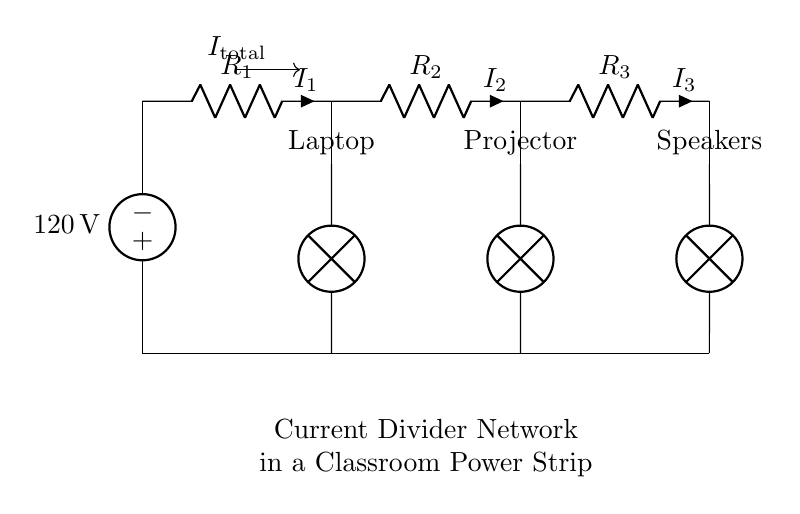What is the supply voltage in this circuit? The supply voltage is indicated in the circuit diagram as the voltage source labeled 120 volts.
Answer: 120 volts What are the three components connected to this current divider? The components connected are a laptop, a projector, and speakers, as marked in the diagram.
Answer: Laptop, projector, speakers What is the total current entering the current divider? The total current entering is labeled as I total, but the specific value is not provided in the circuit diagram. However, it represents the current flowing from the voltage source.
Answer: I total Which resistor is connected to the laptop? The resistor connected to the laptop is labeled R one, corresponding to the first branch of the current divider.
Answer: R one How many outlets are derived from the current divider in this diagram? There are three outlets derived from the current divider, corresponding to the connections for the laptop, projector, and speakers.
Answer: Three What type of circuit is implemented in this diagram? The implemented circuit is a current divider, which splits the total current into different branches for the different components.
Answer: Current divider Which component would likely consume the most power in this setup? The laptop is likely to consume the most power, as it is typically the most power-hungry device among the three components connected.
Answer: Laptop 